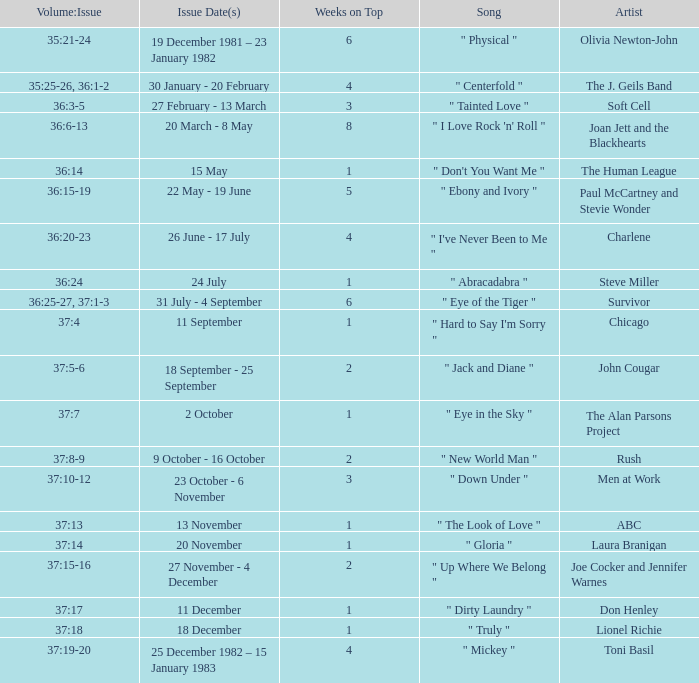When was the issue with an artist's portrayal of men at work published? 23 October - 6 November. 